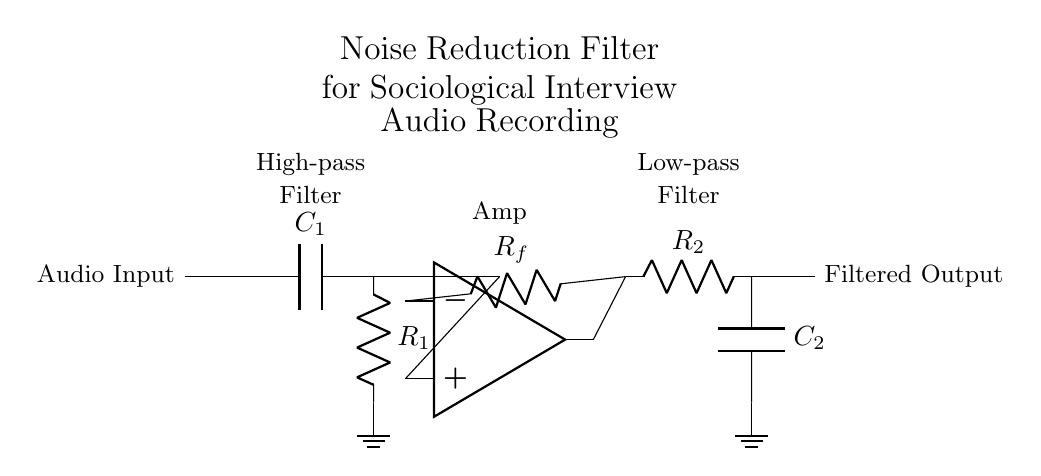What type of filter is used in this circuit? The circuit uses a high-pass filter followed by a low-pass filter. The high-pass filter is indicated by the capacitor followed by the resistor, and the low-pass filter follows the amplifier with the resistor and capacitor configuration.
Answer: High-pass and low-pass filters What is the function of the amplifier in this circuit? The amplifier boosts the signal amplitude. It is placed after the high-pass filter and before the low-pass filter to ensure the filtered signal is strong enough for output.
Answer: Signal amplification Which component indicates the high-pass filter in the circuit? The capacitor, labeled C1, is the component that signifies the high-pass filter. Its placement in the circuit design allows high-frequency signals to pass while attenuating lower frequencies.
Answer: Capacitor C1 How many resistors are present in this circuit? There are two resistors present in the circuit, R1 and R2, which are used in the high-pass and low-pass filter sections, respectively.
Answer: Two resistors What is the role of capacitor C2 in the circuit? Capacitor C2 is part of the low-pass filter, which allows low-frequency signals to pass while attenuating high-frequency noise, ensuring that the output is cleaner for sociological interviews.
Answer: Noise filtering What is connected to ground in the circuit? The ground is connected to the bottom terminals of both capacitors, C1 and C2, indicating the reference point for the circuit and completing the circuit paths for the respective filters.
Answer: Capacitors C1 and C2 